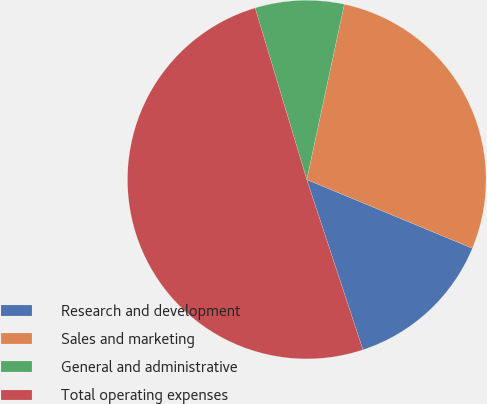Convert chart. <chart><loc_0><loc_0><loc_500><loc_500><pie_chart><fcel>Research and development<fcel>Sales and marketing<fcel>General and administrative<fcel>Total operating expenses<nl><fcel>13.67%<fcel>27.9%<fcel>8.01%<fcel>50.42%<nl></chart> 